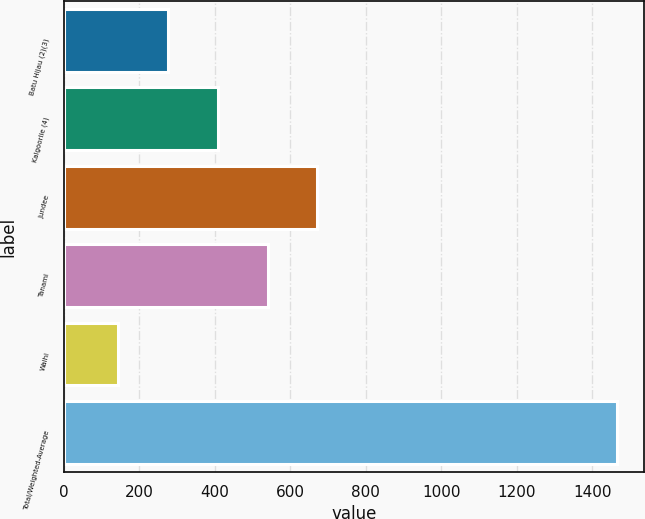Convert chart to OTSL. <chart><loc_0><loc_0><loc_500><loc_500><bar_chart><fcel>Batu Hijau (2)(3)<fcel>Kalgoorlie (4)<fcel>Jundee<fcel>Tanami<fcel>Waihi<fcel>Total/Weighted-Average<nl><fcel>276<fcel>408<fcel>672<fcel>540<fcel>144<fcel>1464<nl></chart> 